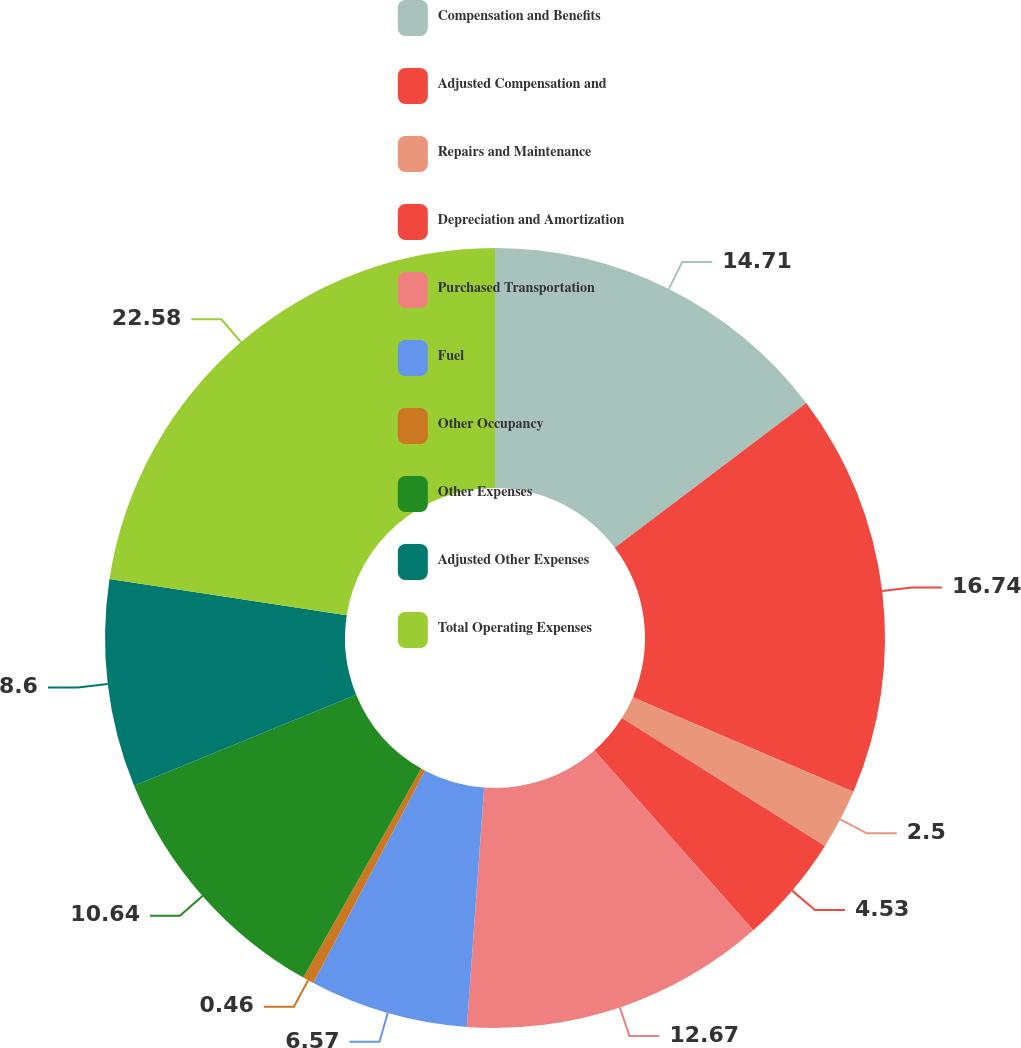Convert chart to OTSL. <chart><loc_0><loc_0><loc_500><loc_500><pie_chart><fcel>Compensation and Benefits<fcel>Adjusted Compensation and<fcel>Repairs and Maintenance<fcel>Depreciation and Amortization<fcel>Purchased Transportation<fcel>Fuel<fcel>Other Occupancy<fcel>Other Expenses<fcel>Adjusted Other Expenses<fcel>Total Operating Expenses<nl><fcel>14.71%<fcel>16.74%<fcel>2.5%<fcel>4.53%<fcel>12.67%<fcel>6.57%<fcel>0.46%<fcel>10.64%<fcel>8.6%<fcel>22.58%<nl></chart> 